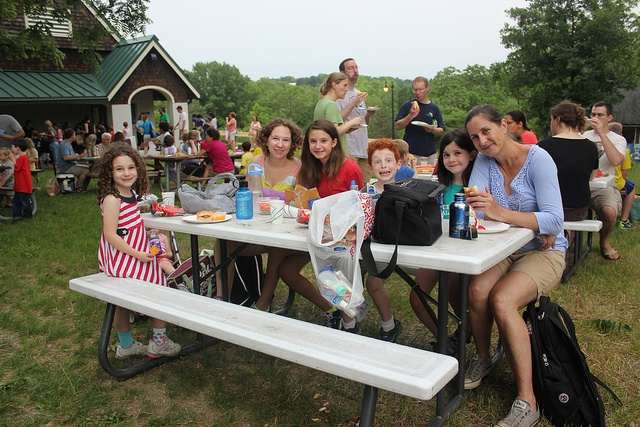Describe the objects in this image and their specific colors. I can see people in black, darkgreen, and gray tones, bench in black, lightgray, darkgray, and gray tones, people in black, gray, tan, and darkgray tones, dining table in black, lightgray, and darkgray tones, and backpack in black, olive, gray, and maroon tones in this image. 